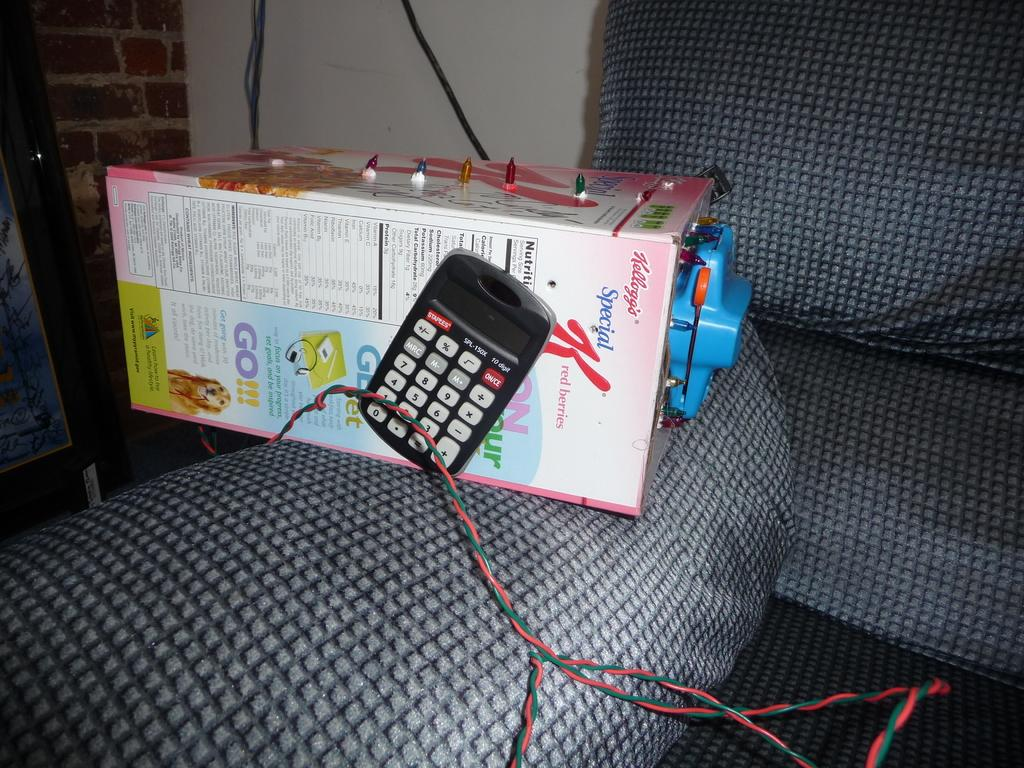<image>
Summarize the visual content of the image. A box with Kellogg on it sitting on a seat. 